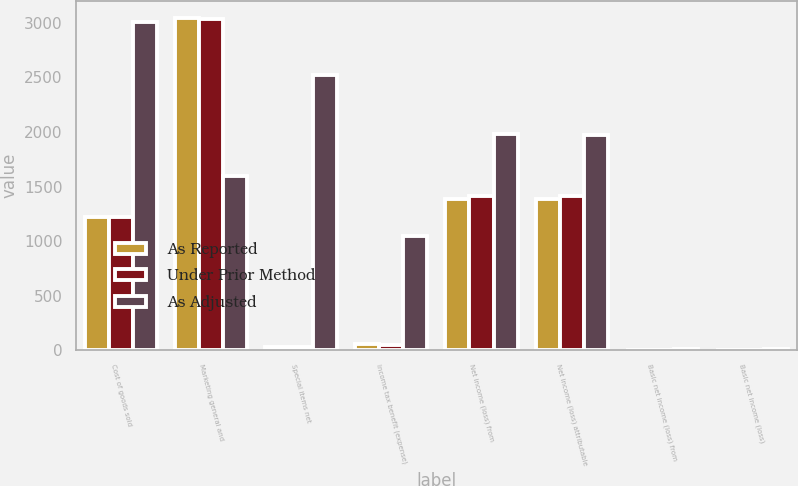Convert chart to OTSL. <chart><loc_0><loc_0><loc_500><loc_500><stacked_bar_chart><ecel><fcel>Cost of goods sold<fcel>Marketing general and<fcel>Special items net<fcel>Income tax benefit (expense)<fcel>Net income (loss) from<fcel>Net income (loss) attributable<fcel>Basic net income (loss) from<fcel>Basic net income (loss)<nl><fcel>As Reported<fcel>1217.1<fcel>3046.2<fcel>28.1<fcel>59.5<fcel>1383.5<fcel>1385<fcel>6.42<fcel>6.43<nl><fcel>Under Prior Method<fcel>1217.1<fcel>3032.4<fcel>28.1<fcel>53.2<fcel>1412.7<fcel>1414.2<fcel>6.56<fcel>6.57<nl><fcel>As Adjusted<fcel>3003.1<fcel>1597.3<fcel>2523.9<fcel>1050.7<fcel>1978.7<fcel>1975.9<fcel>9.33<fcel>9.32<nl></chart> 